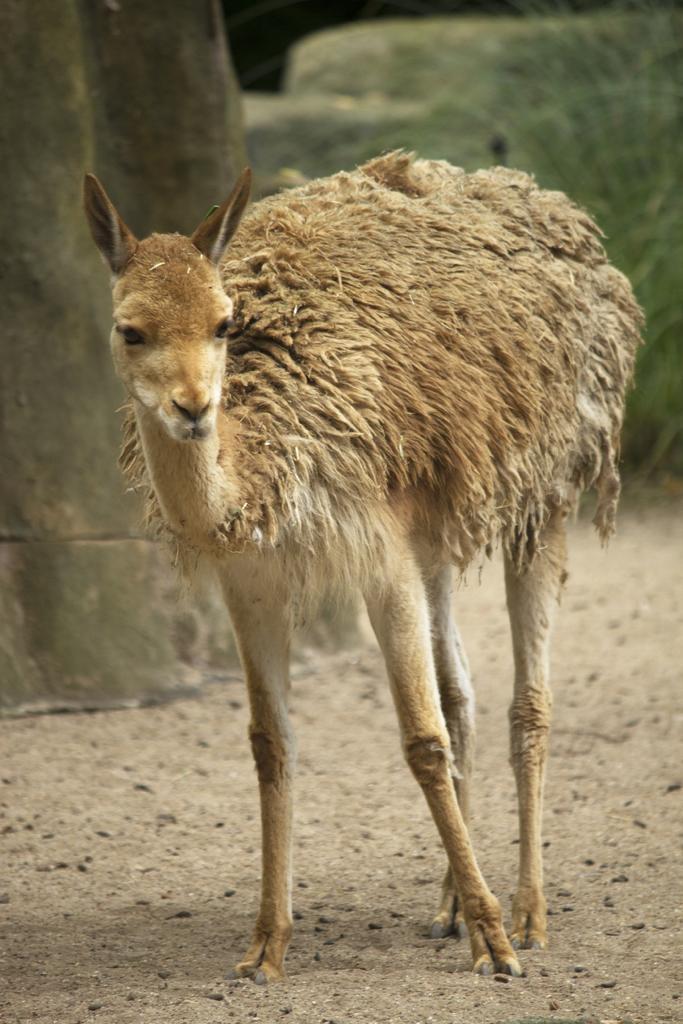How would you summarize this image in a sentence or two? In this picture, we can see an animal on the ground, and we can see some object on the left side of the picture, the blurred background. 